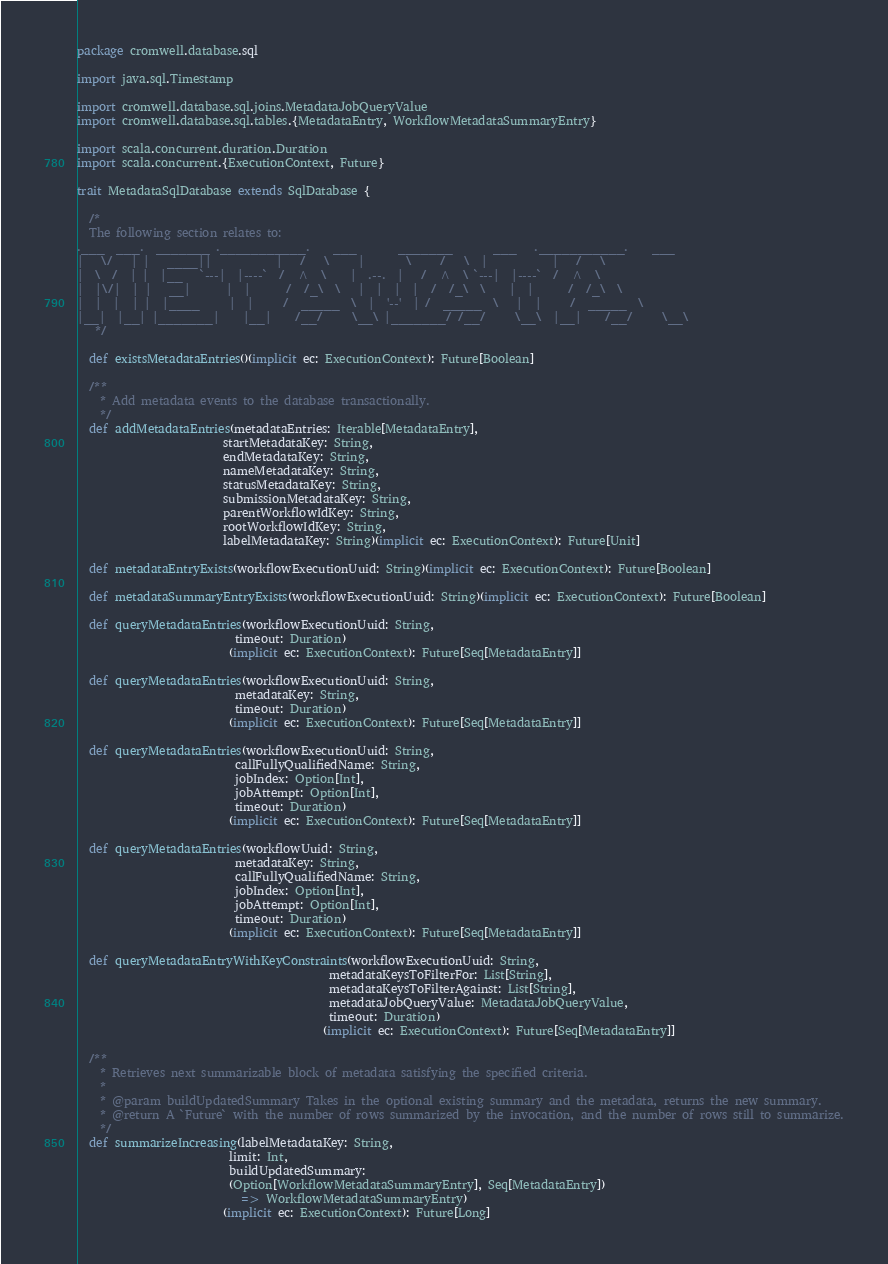Convert code to text. <code><loc_0><loc_0><loc_500><loc_500><_Scala_>package cromwell.database.sql

import java.sql.Timestamp

import cromwell.database.sql.joins.MetadataJobQueryValue
import cromwell.database.sql.tables.{MetadataEntry, WorkflowMetadataSummaryEntry}

import scala.concurrent.duration.Duration
import scala.concurrent.{ExecutionContext, Future}

trait MetadataSqlDatabase extends SqlDatabase {

  /*
  The following section relates to:
.___  ___.  _______ .___________.    ___       _______       ___   .___________.    ___
|   \/   | |   ____||           |   /   \     |       \     /   \  |           |   /   \
|  \  /  | |  |__   `---|  |----`  /  ^  \    |  .--.  |   /  ^  \ `---|  |----`  /  ^  \
|  |\/|  | |   __|      |  |      /  /_\  \   |  |  |  |  /  /_\  \    |  |      /  /_\  \
|  |  |  | |  |____     |  |     /  _____  \  |  '--'  | /  _____  \   |  |     /  _____  \
|__|  |__| |_______|    |__|    /__/     \__\ |_______/ /__/     \__\  |__|    /__/     \__\
   */

  def existsMetadataEntries()(implicit ec: ExecutionContext): Future[Boolean]

  /**
    * Add metadata events to the database transactionally.
    */
  def addMetadataEntries(metadataEntries: Iterable[MetadataEntry],
                         startMetadataKey: String,
                         endMetadataKey: String,
                         nameMetadataKey: String,
                         statusMetadataKey: String,
                         submissionMetadataKey: String,
                         parentWorkflowIdKey: String,
                         rootWorkflowIdKey: String,
                         labelMetadataKey: String)(implicit ec: ExecutionContext): Future[Unit]

  def metadataEntryExists(workflowExecutionUuid: String)(implicit ec: ExecutionContext): Future[Boolean]

  def metadataSummaryEntryExists(workflowExecutionUuid: String)(implicit ec: ExecutionContext): Future[Boolean]

  def queryMetadataEntries(workflowExecutionUuid: String,
                           timeout: Duration)
                          (implicit ec: ExecutionContext): Future[Seq[MetadataEntry]]

  def queryMetadataEntries(workflowExecutionUuid: String,
                           metadataKey: String,
                           timeout: Duration)
                          (implicit ec: ExecutionContext): Future[Seq[MetadataEntry]]

  def queryMetadataEntries(workflowExecutionUuid: String,
                           callFullyQualifiedName: String,
                           jobIndex: Option[Int],
                           jobAttempt: Option[Int],
                           timeout: Duration)
                          (implicit ec: ExecutionContext): Future[Seq[MetadataEntry]]

  def queryMetadataEntries(workflowUuid: String,
                           metadataKey: String,
                           callFullyQualifiedName: String,
                           jobIndex: Option[Int],
                           jobAttempt: Option[Int],
                           timeout: Duration)
                          (implicit ec: ExecutionContext): Future[Seq[MetadataEntry]]

  def queryMetadataEntryWithKeyConstraints(workflowExecutionUuid: String,
                                           metadataKeysToFilterFor: List[String],
                                           metadataKeysToFilterAgainst: List[String],
                                           metadataJobQueryValue: MetadataJobQueryValue,
                                           timeout: Duration)
                                          (implicit ec: ExecutionContext): Future[Seq[MetadataEntry]]

  /**
    * Retrieves next summarizable block of metadata satisfying the specified criteria.
    *
    * @param buildUpdatedSummary Takes in the optional existing summary and the metadata, returns the new summary.
    * @return A `Future` with the number of rows summarized by the invocation, and the number of rows still to summarize.
    */
  def summarizeIncreasing(labelMetadataKey: String,
                          limit: Int,
                          buildUpdatedSummary:
                          (Option[WorkflowMetadataSummaryEntry], Seq[MetadataEntry])
                            => WorkflowMetadataSummaryEntry)
                         (implicit ec: ExecutionContext): Future[Long]
</code> 